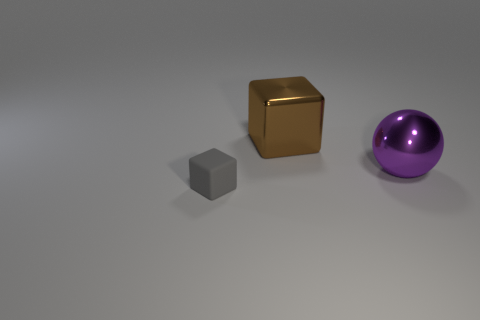What size is the other thing that is the same shape as the large brown object?
Keep it short and to the point. Small. There is a thing that is to the left of the large brown block; is its shape the same as the big brown shiny object?
Make the answer very short. Yes. What color is the thing that is the same size as the brown cube?
Ensure brevity in your answer.  Purple. Do the tiny gray thing and the brown shiny object have the same shape?
Your response must be concise. Yes. What color is the cube in front of the thing that is behind the large thing in front of the large brown metallic thing?
Give a very brief answer. Gray. How many other objects have the same shape as the small gray thing?
Provide a short and direct response. 1. What is the size of the thing that is in front of the large metal object in front of the big metallic block?
Offer a terse response. Small. Is the size of the sphere the same as the brown metallic cube?
Ensure brevity in your answer.  Yes. There is a block behind the cube in front of the shiny cube; are there any objects that are to the left of it?
Your answer should be compact. Yes. What size is the brown shiny object?
Provide a succinct answer. Large. 